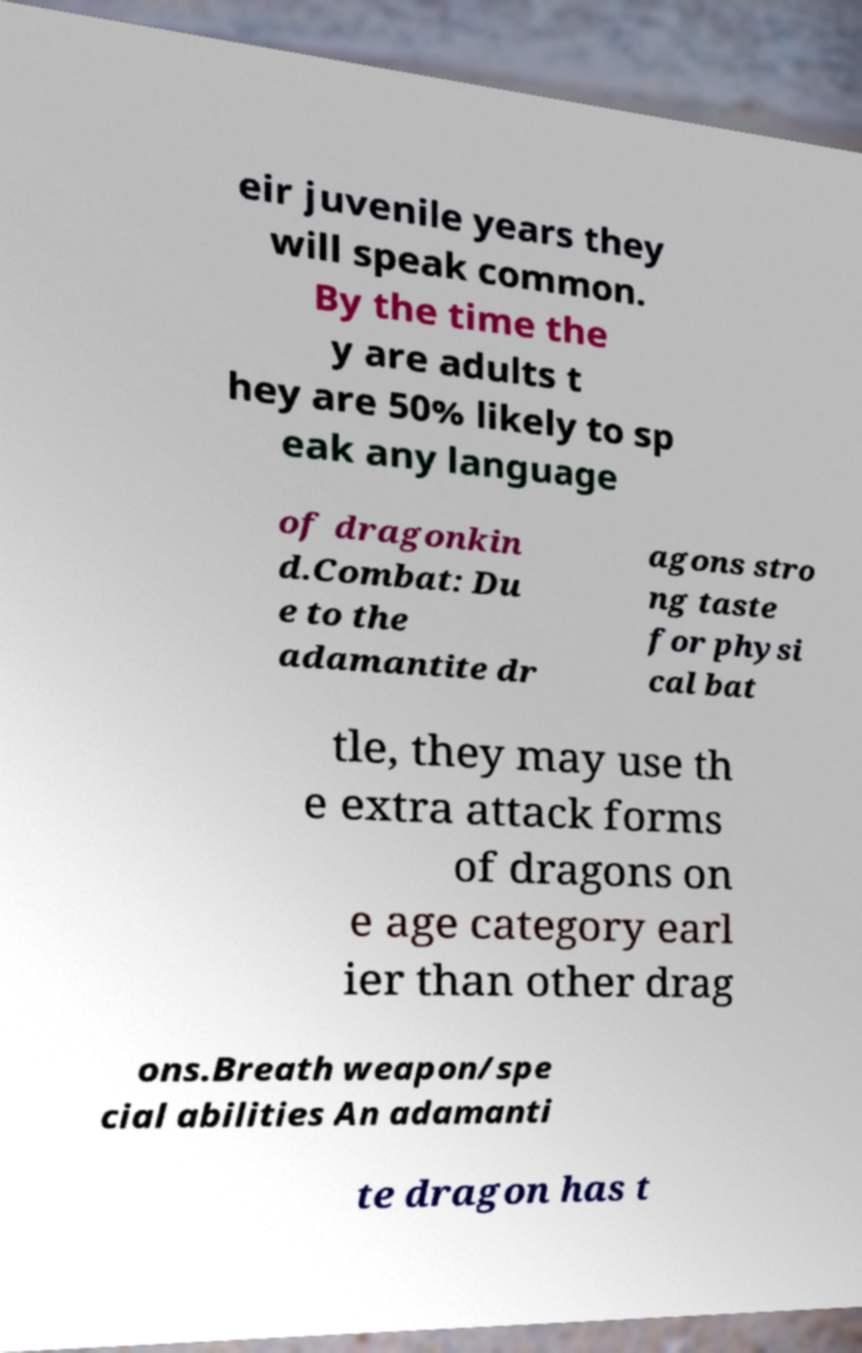Could you extract and type out the text from this image? eir juvenile years they will speak common. By the time the y are adults t hey are 50% likely to sp eak any language of dragonkin d.Combat: Du e to the adamantite dr agons stro ng taste for physi cal bat tle, they may use th e extra attack forms of dragons on e age category earl ier than other drag ons.Breath weapon/spe cial abilities An adamanti te dragon has t 